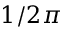<formula> <loc_0><loc_0><loc_500><loc_500>1 / 2 \pi</formula> 